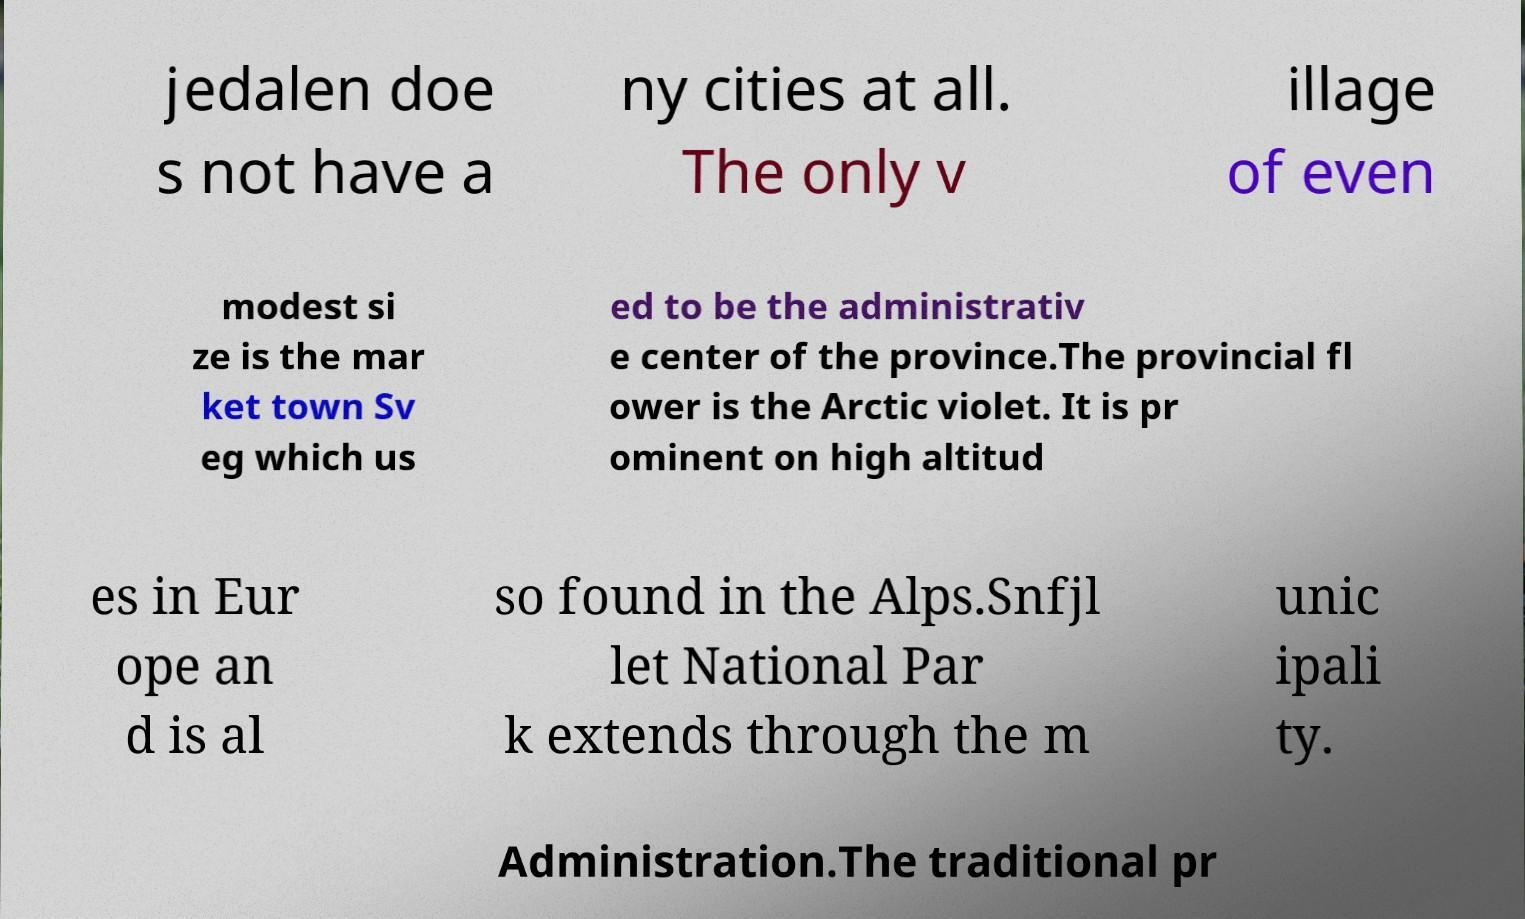I need the written content from this picture converted into text. Can you do that? jedalen doe s not have a ny cities at all. The only v illage of even modest si ze is the mar ket town Sv eg which us ed to be the administrativ e center of the province.The provincial fl ower is the Arctic violet. It is pr ominent on high altitud es in Eur ope an d is al so found in the Alps.Snfjl let National Par k extends through the m unic ipali ty. Administration.The traditional pr 